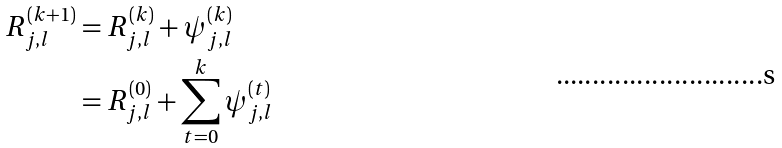<formula> <loc_0><loc_0><loc_500><loc_500>R _ { j , l } ^ { ( k + 1 ) } & = R _ { j , l } ^ { ( k ) } + \psi _ { j , l } ^ { ( k ) } \\ & = R _ { j , l } ^ { ( 0 ) } + \sum _ { t = 0 } ^ { k } \psi _ { j , l } ^ { ( t ) }</formula> 